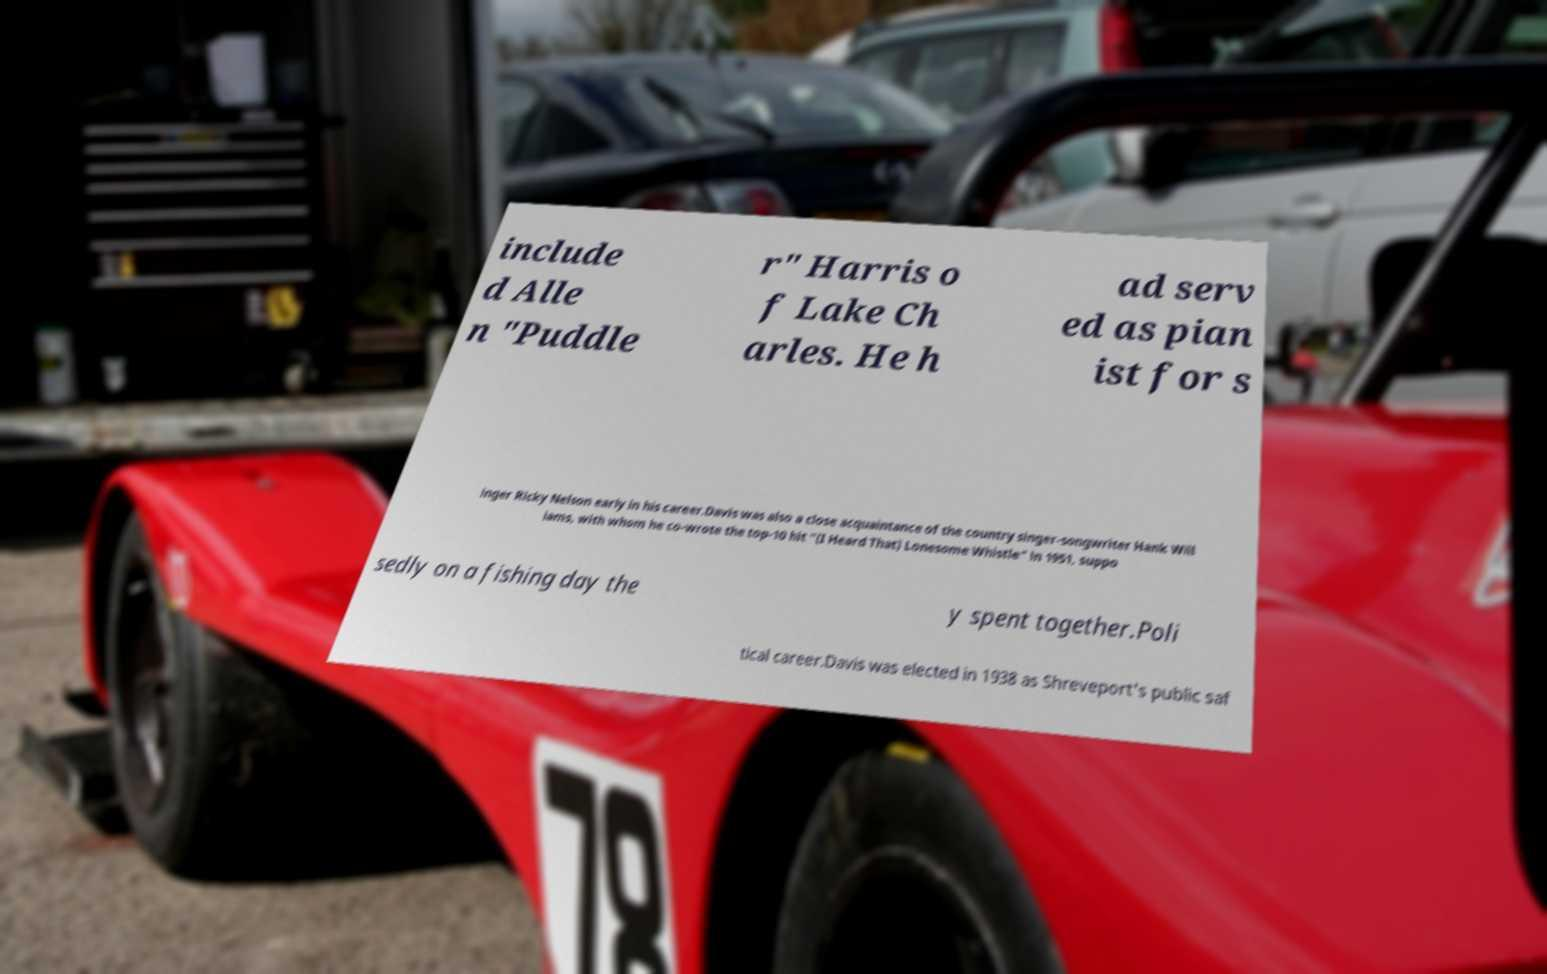Please identify and transcribe the text found in this image. include d Alle n "Puddle r" Harris o f Lake Ch arles. He h ad serv ed as pian ist for s inger Ricky Nelson early in his career.Davis was also a close acquaintance of the country singer-songwriter Hank Will iams, with whom he co-wrote the top-10 hit "(I Heard That) Lonesome Whistle" in 1951, suppo sedly on a fishing day the y spent together.Poli tical career.Davis was elected in 1938 as Shreveport's public saf 